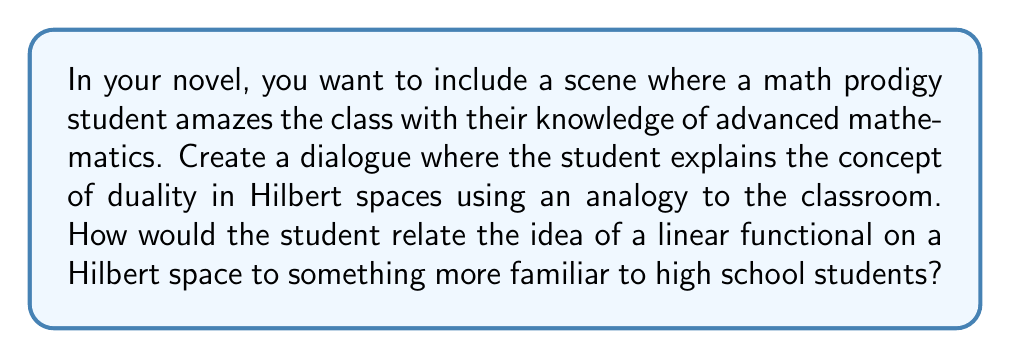Can you solve this math problem? To answer this question, we need to create an analogy that relates the abstract concept of duality in Hilbert spaces to something more tangible and familiar to high school students. Here's a possible explanation the prodigy student might give:

1. First, the student could introduce the concept of a Hilbert space as a generalization of our familiar three-dimensional space, but with potentially infinite dimensions. In the classroom analogy, each student could represent a dimension of the space.

2. The student could then explain that a linear functional on this space is like a special kind of grading system. Just as a teacher assigns a single number (grade) to each student based on their performance, a linear functional assigns a single number to each point (vector) in the Hilbert space.

3. The key property of linearity could be explained as follows: If you combine two students' performances (like adding their test scores), the grade of the combination would be the sum of their individual grades. Mathematically, this is expressed as:

   $$f(ax + by) = af(x) + bf(y)$$

   where $f$ is the linear functional, $x$ and $y$ are vectors in the Hilbert space, and $a$ and $b$ are scalars.

4. The student could then introduce the Riesz representation theorem, which states that every continuous linear functional on a Hilbert space can be represented as an inner product with a unique vector in that space. In the classroom analogy, this means there's a special "ideal student" for each grading system, such that the grade for any student is just how similar they are to this ideal student (where similarity is measured by the inner product).

5. The duality comes from the fact that we can go back and forth between these linear functionals and vectors in the space. Each vector in the space defines a unique linear functional, and each linear functional corresponds to a unique vector.

6. Finally, the student could mention some applications, such as in quantum mechanics where observables (linear functionals) are represented by operators, or in signal processing where the Fourier transform can be viewed as a change of basis in a Hilbert space.

This explanation provides a relatable analogy while touching on the key mathematical concepts of Hilbert space duality.
Answer: The student could relate the idea of a linear functional on a Hilbert space to a special grading system in the classroom. Each linear functional is like a unique way of assigning grades, where the grade (scalar) given to each student (vector) depends linearly on their performance. The Riesz representation theorem would be explained as the existence of an "ideal student" for each grading system, where grades are determined by similarity to this ideal student. 